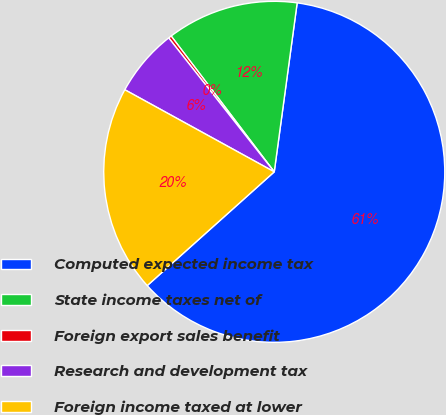Convert chart. <chart><loc_0><loc_0><loc_500><loc_500><pie_chart><fcel>Computed expected income tax<fcel>State income taxes net of<fcel>Foreign export sales benefit<fcel>Research and development tax<fcel>Foreign income taxed at lower<nl><fcel>61.23%<fcel>12.48%<fcel>0.29%<fcel>6.38%<fcel>19.62%<nl></chart> 